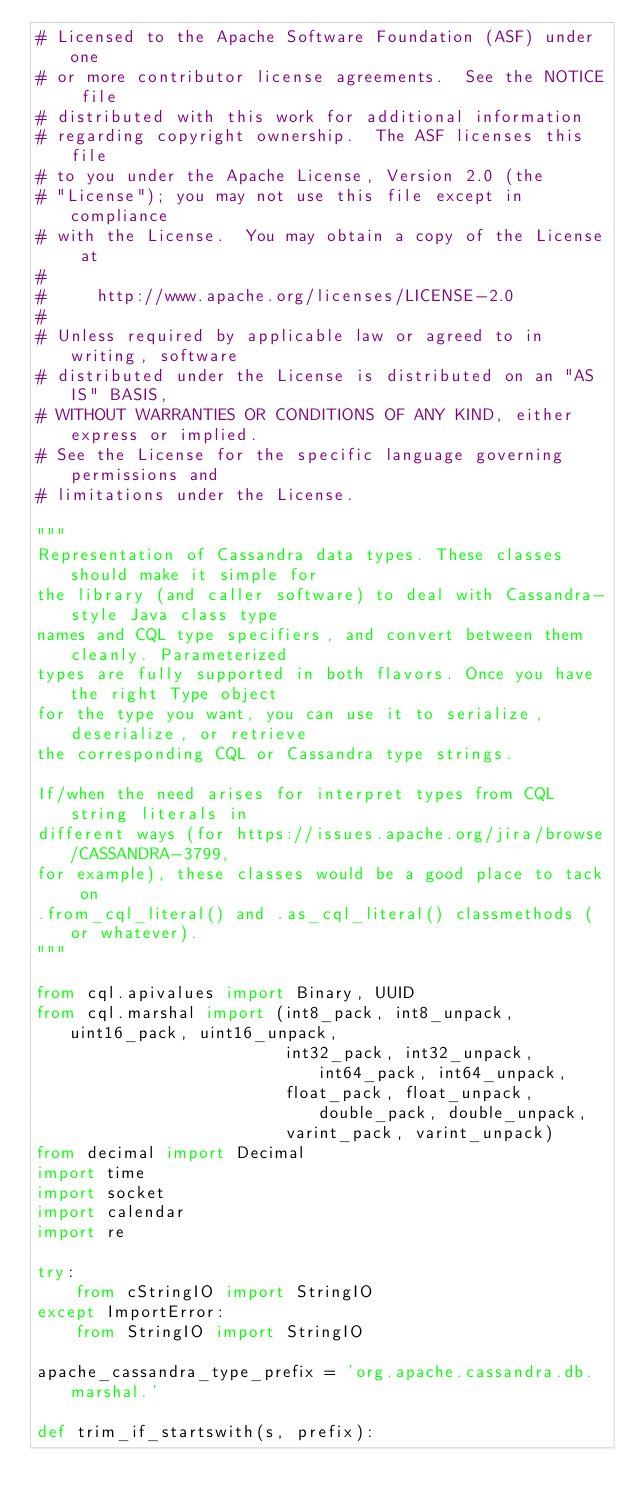<code> <loc_0><loc_0><loc_500><loc_500><_Python_># Licensed to the Apache Software Foundation (ASF) under one
# or more contributor license agreements.  See the NOTICE file
# distributed with this work for additional information
# regarding copyright ownership.  The ASF licenses this file
# to you under the Apache License, Version 2.0 (the
# "License"); you may not use this file except in compliance
# with the License.  You may obtain a copy of the License at
#
#     http://www.apache.org/licenses/LICENSE-2.0
#
# Unless required by applicable law or agreed to in writing, software
# distributed under the License is distributed on an "AS IS" BASIS,
# WITHOUT WARRANTIES OR CONDITIONS OF ANY KIND, either express or implied.
# See the License for the specific language governing permissions and
# limitations under the License.

"""
Representation of Cassandra data types. These classes should make it simple for
the library (and caller software) to deal with Cassandra-style Java class type
names and CQL type specifiers, and convert between them cleanly. Parameterized
types are fully supported in both flavors. Once you have the right Type object
for the type you want, you can use it to serialize, deserialize, or retrieve
the corresponding CQL or Cassandra type strings.

If/when the need arises for interpret types from CQL string literals in
different ways (for https://issues.apache.org/jira/browse/CASSANDRA-3799,
for example), these classes would be a good place to tack on
.from_cql_literal() and .as_cql_literal() classmethods (or whatever).
"""

from cql.apivalues import Binary, UUID
from cql.marshal import (int8_pack, int8_unpack, uint16_pack, uint16_unpack,
                         int32_pack, int32_unpack, int64_pack, int64_unpack,
                         float_pack, float_unpack, double_pack, double_unpack,
                         varint_pack, varint_unpack)
from decimal import Decimal
import time
import socket
import calendar
import re

try:
    from cStringIO import StringIO
except ImportError:
    from StringIO import StringIO

apache_cassandra_type_prefix = 'org.apache.cassandra.db.marshal.'

def trim_if_startswith(s, prefix):</code> 